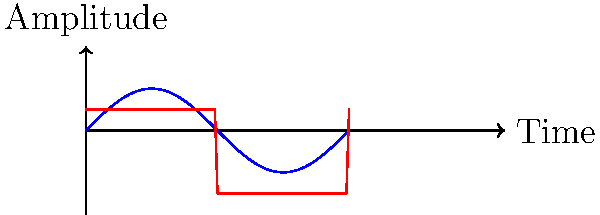In the oscilloscope display above, two common audio waveforms are shown. Identify the blue waveform and explain how it differs from the red waveform in terms of harmonic content and potential applications in audio production. To answer this question, let's analyze the waveforms step-by-step:

1. Waveform Identification:
   - The blue waveform is a sine wave, characterized by its smooth, periodic oscillation.
   - The red waveform is a square wave, characterized by its abrupt transitions between two fixed voltage levels.

2. Harmonic Content:
   - Sine wave (blue):
     a. Contains only one frequency component (the fundamental frequency).
     b. Has no harmonics, making it the purest tone possible.
   - Square wave (red):
     a. Contains the fundamental frequency and odd harmonics.
     b. The amplitude of harmonics decreases as 1/n, where n is the harmonic number.

3. Harmonic Series:
   - Sine wave: $f(t) = A \sin(2\pi ft)$
   - Square wave: $f(t) = \frac{4A}{\pi} \sum_{n=1,3,5,...}^{\infty} \frac{1}{n} \sin(2\pi nft)$

4. Spectral Characteristics:
   - Sine wave: Single spike in the frequency domain.
   - Square wave: Multiple spikes at odd harmonics with decreasing amplitude.

5. Applications in Audio Production:
   - Sine wave:
     a. Testing and calibration of audio equipment.
     b. Synthesis of pure tones for electronic instruments.
     c. Reference for tuning instruments.
   - Square wave:
     a. Synthesis of rich, harmonically complex tones.
     b. Creating harsh or "buzzy" sounds in electronic music.
     c. Testing frequency response and distortion in audio systems.

The main difference lies in their harmonic content: the sine wave is harmonically pure, while the square wave is rich in odd harmonics, making it more complex and tonally diverse.
Answer: The blue waveform is a sine wave, which differs from the square wave (red) by containing only the fundamental frequency without harmonics, resulting in a purer tone used for calibration and reference, while the square wave has odd harmonics suitable for creating rich, complex tones in audio synthesis. 